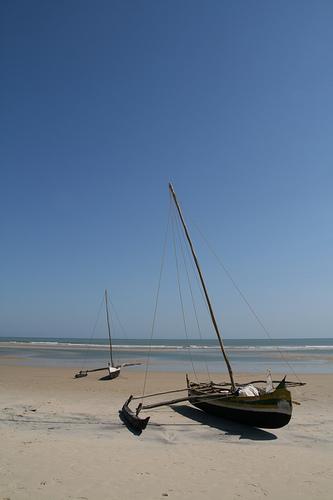How many people are on the boat?
Quick response, please. 0. Is the ocean at low tide?
Be succinct. Yes. Will there be a storm?
Quick response, please. No. What is sticking out of the sand?
Quick response, please. Boat. What type of boats are pictured?
Write a very short answer. Sailboats. Are the boats in the ocean?
Write a very short answer. No. 